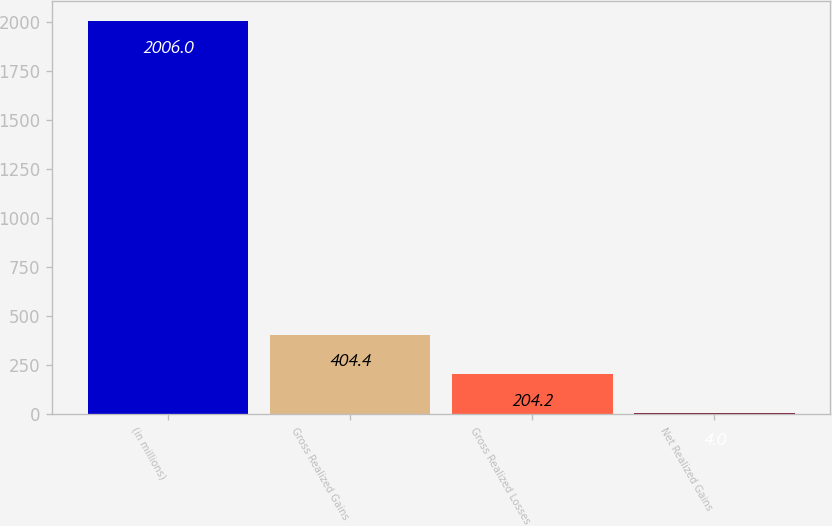<chart> <loc_0><loc_0><loc_500><loc_500><bar_chart><fcel>(in millions)<fcel>Gross Realized Gains<fcel>Gross Realized Losses<fcel>Net Realized Gains<nl><fcel>2006<fcel>404.4<fcel>204.2<fcel>4<nl></chart> 